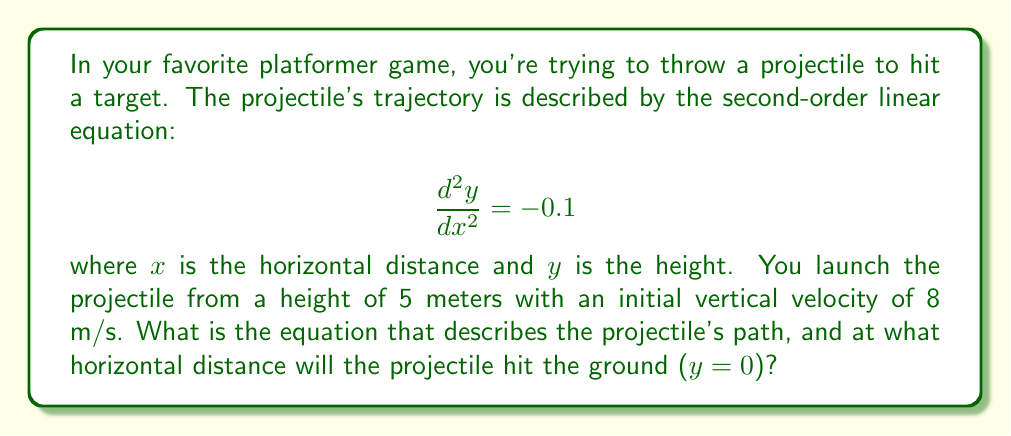Solve this math problem. Let's approach this step-by-step:

1) The general solution to the second-order linear equation $\frac{d^2y}{dx^2} = -0.1$ is:

   $$y = -0.05x^2 + C_1x + C_2$$

   where $C_1$ and $C_2$ are constants we need to determine.

2) We're given two initial conditions:
   - The initial height is 5 meters: $y(0) = 5$
   - The initial vertical velocity is 8 m/s: $\frac{dy}{dx}(0) = 8$

3) Using the first condition:
   $$5 = -0.05(0)^2 + C_1(0) + C_2$$
   $$C_2 = 5$$

4) For the second condition, we need to differentiate $y$ with respect to $x$:
   $$\frac{dy}{dx} = -0.1x + C_1$$
   
   At $x = 0$, this equals 8:
   $$8 = -0.1(0) + C_1$$
   $$C_1 = 8$$

5) Now we have our complete equation:
   $$y = -0.05x^2 + 8x + 5$$

6) To find where the projectile hits the ground, we set $y = 0$ and solve for $x$:
   $$0 = -0.05x^2 + 8x + 5$$
   $$0.05x^2 - 8x - 5 = 0$$

7) This is a quadratic equation. We can solve it using the quadratic formula:
   $$x = \frac{-b \pm \sqrt{b^2 - 4ac}}{2a}$$
   where $a = 0.05$, $b = -8$, and $c = -5$

8) Plugging in these values:
   $$x = \frac{8 \pm \sqrt{64 + 1}}{0.1} = \frac{8 \pm \sqrt{65}}{0.1}$$

9) This gives us two solutions:
   $$x_1 = \frac{8 + \sqrt{65}}{0.1} \approx 160.56$$
   $$x_2 = \frac{8 - \sqrt{65}}{0.1} \approx -0.56$$

10) Since negative distance doesn't make sense in this context, we take the positive solution.

Therefore, the projectile will hit the ground approximately 160.56 meters from the launch point.
Answer: The equation describing the projectile's path is $y = -0.05x^2 + 8x + 5$, and it will hit the ground approximately 160.56 meters from the launch point. 